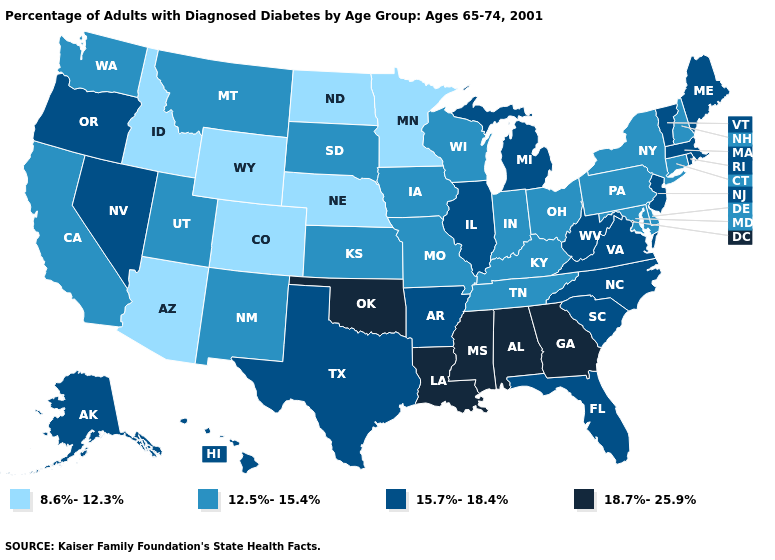What is the value of Delaware?
Answer briefly. 12.5%-15.4%. Name the states that have a value in the range 12.5%-15.4%?
Write a very short answer. California, Connecticut, Delaware, Indiana, Iowa, Kansas, Kentucky, Maryland, Missouri, Montana, New Hampshire, New Mexico, New York, Ohio, Pennsylvania, South Dakota, Tennessee, Utah, Washington, Wisconsin. Which states hav the highest value in the South?
Be succinct. Alabama, Georgia, Louisiana, Mississippi, Oklahoma. Does Virginia have the lowest value in the USA?
Give a very brief answer. No. Does Kansas have the same value as Colorado?
Short answer required. No. Which states hav the highest value in the MidWest?
Concise answer only. Illinois, Michigan. Which states have the lowest value in the USA?
Write a very short answer. Arizona, Colorado, Idaho, Minnesota, Nebraska, North Dakota, Wyoming. Name the states that have a value in the range 8.6%-12.3%?
Short answer required. Arizona, Colorado, Idaho, Minnesota, Nebraska, North Dakota, Wyoming. Does Oklahoma have the highest value in the USA?
Quick response, please. Yes. Name the states that have a value in the range 18.7%-25.9%?
Keep it brief. Alabama, Georgia, Louisiana, Mississippi, Oklahoma. What is the highest value in the USA?
Answer briefly. 18.7%-25.9%. Name the states that have a value in the range 18.7%-25.9%?
Quick response, please. Alabama, Georgia, Louisiana, Mississippi, Oklahoma. Name the states that have a value in the range 18.7%-25.9%?
Concise answer only. Alabama, Georgia, Louisiana, Mississippi, Oklahoma. Which states hav the highest value in the South?
Be succinct. Alabama, Georgia, Louisiana, Mississippi, Oklahoma. Name the states that have a value in the range 12.5%-15.4%?
Quick response, please. California, Connecticut, Delaware, Indiana, Iowa, Kansas, Kentucky, Maryland, Missouri, Montana, New Hampshire, New Mexico, New York, Ohio, Pennsylvania, South Dakota, Tennessee, Utah, Washington, Wisconsin. 